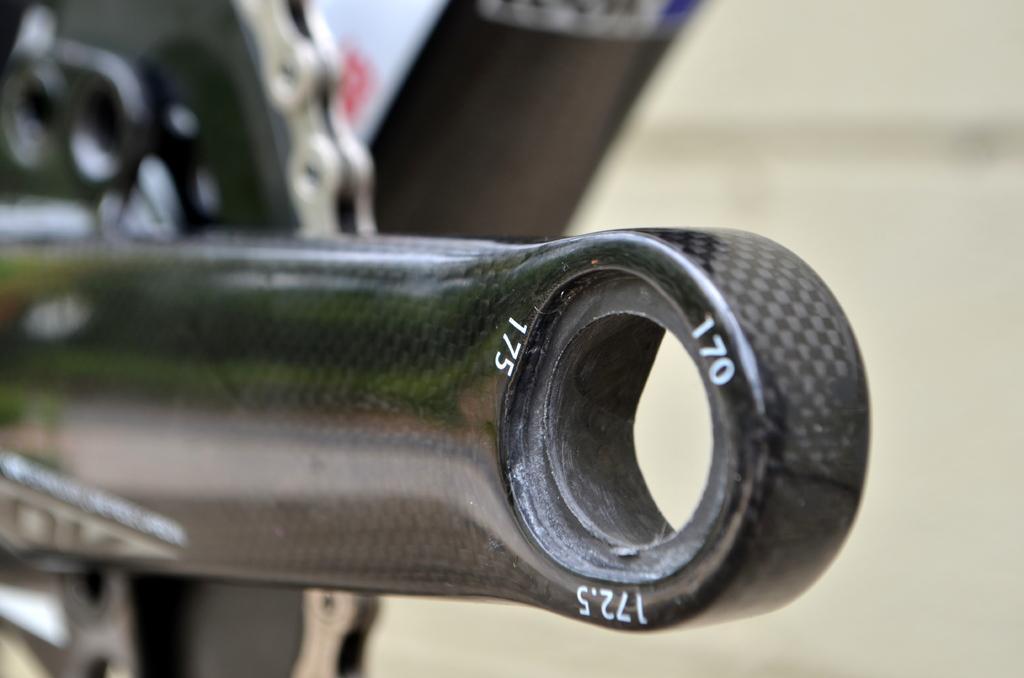Describe this image in one or two sentences. In this image there are few parts of a bicycle. Background is blurry. 